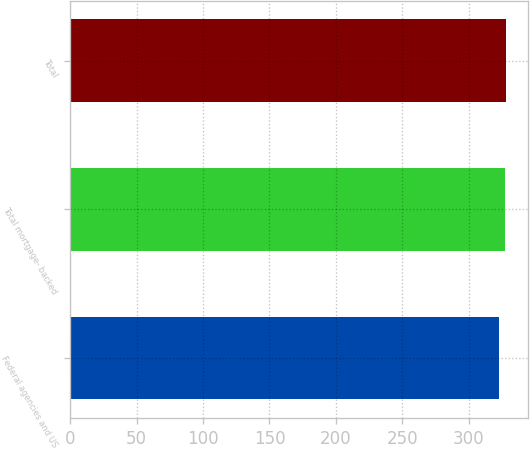<chart> <loc_0><loc_0><loc_500><loc_500><bar_chart><fcel>Federal agencies and US<fcel>Total mortgage- backed<fcel>Total<nl><fcel>323<fcel>327<fcel>328<nl></chart> 